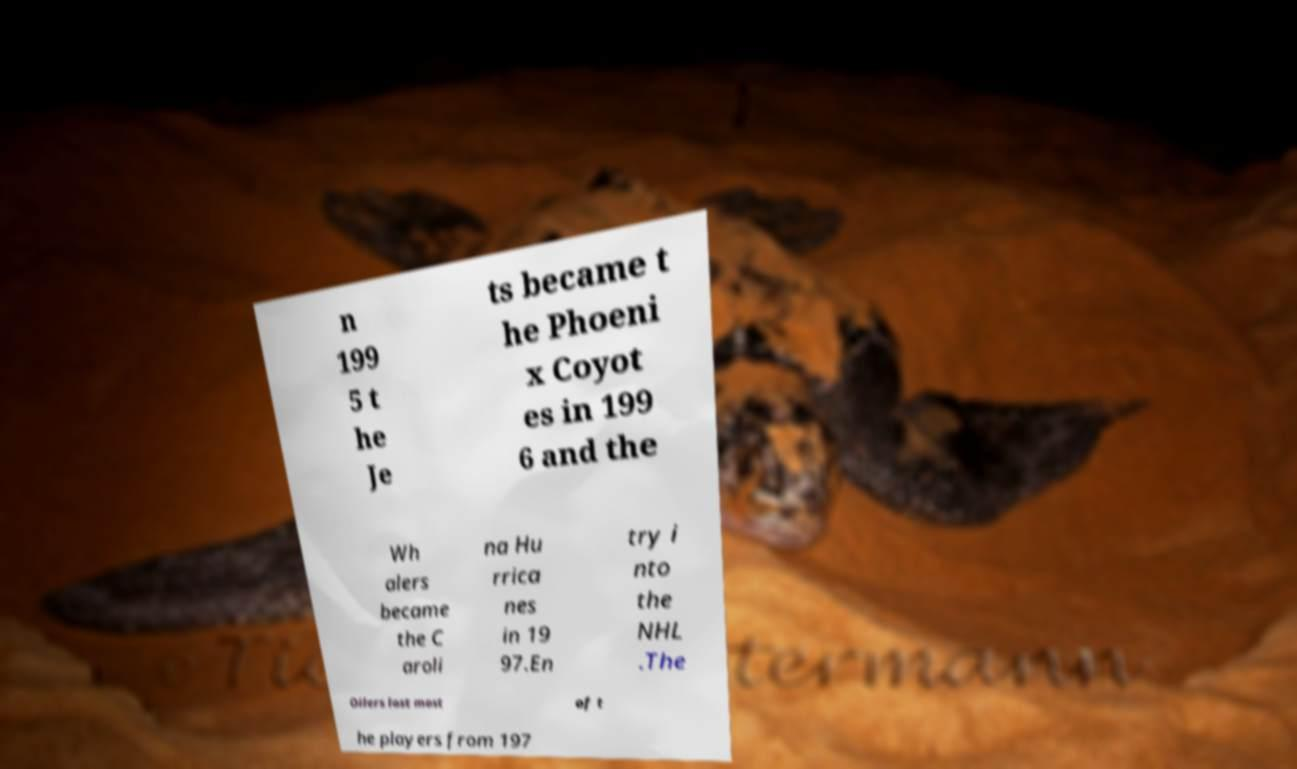I need the written content from this picture converted into text. Can you do that? n 199 5 t he Je ts became t he Phoeni x Coyot es in 199 6 and the Wh alers became the C aroli na Hu rrica nes in 19 97.En try i nto the NHL .The Oilers lost most of t he players from 197 